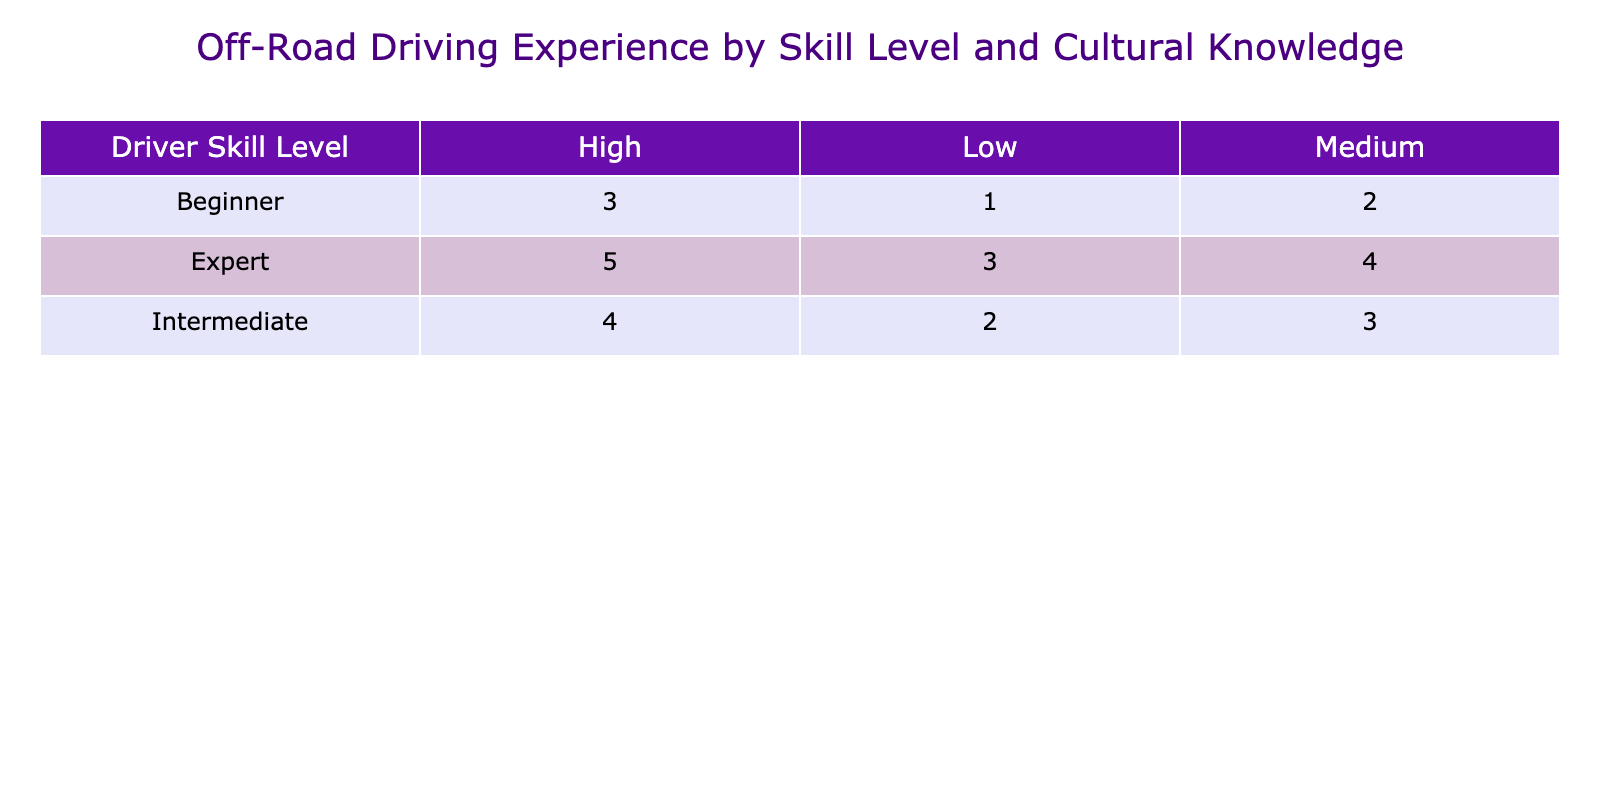What is the highest experience rating for an expert driver with high local cultural knowledge? The table indicates that the high cultural knowledge for expert drivers has an experience rating of 5. This is the maximum value listed.
Answer: 5 What is the experience rating for intermediate drivers with low cultural knowledge? According to the table, the experience rating for intermediate drivers with low cultural knowledge is 2.
Answer: 2 Do beginners have a higher average experience rating than intermediates? To answer this, we can look at the average experience ratings for both groups: Beginners have ratings of 3, 2, and 1, which average to (3 + 2 + 1) / 3 = 2. Intermediate drivers have ratings of 4, 3, and 2, which average to (4 + 3 + 2) / 3 = 3. Therefore, intermediates have a higher average rating than beginners.
Answer: No What is the lowest experience rating recorded for any driver skill level? Scanning the table, the lowest experience rating is 1, which corresponds to beginner drivers with low cultural knowledge.
Answer: 1 What is the total experience rating for all experts with medium cultural knowledge? The table lists one entry for expert drivers with medium cultural knowledge, which is 4. Since there is only one rating, the total is simply 4.
Answer: 4 Which skill level has the lowest experience rating with high cultural knowledge? Looking at the table, we see that the lowest experience rating with high cultural knowledge is attributed to intermediate drivers, which is 4. Therefore, only the beginner and intermediate skill levels qualify, but the least is 4.
Answer: Intermediate What is the average experience rating for drivers with medium cultural knowledge across all skill levels? We will sum the experience ratings for medium cultural knowledge from all skill levels: 2 (beginner) + 3 (intermediate) + 4 (expert) = 9. Then divide by 3, the number of skill levels: 9 / 3 = 3.
Answer: 3 Is there an experienced rating difference of more than 2 between beginners and experts in any cultural knowledge level? Checking the table, it shows that for high cultural knowledge, experts have 5 and beginners have 3; the difference is 2. For medium, experts have 4 and beginners have 2, a difference of 2. For low, experts have 3 and beginners have 1, a difference of 2. In all cases, the difference is exactly 2.
Answer: No What percentage of the total experience ratings do the expert drivers represent? First, we find the total experience ratings: 3 + 2 + 1 + 4 + 3 + 2 + 5 + 4 + 3 = 23. The expert rating is 5 + 4 + 3 = 12. To find the percentage, we calculate (12 / 23) * 100 = 52.17%.
Answer: Approximately 52.17% 